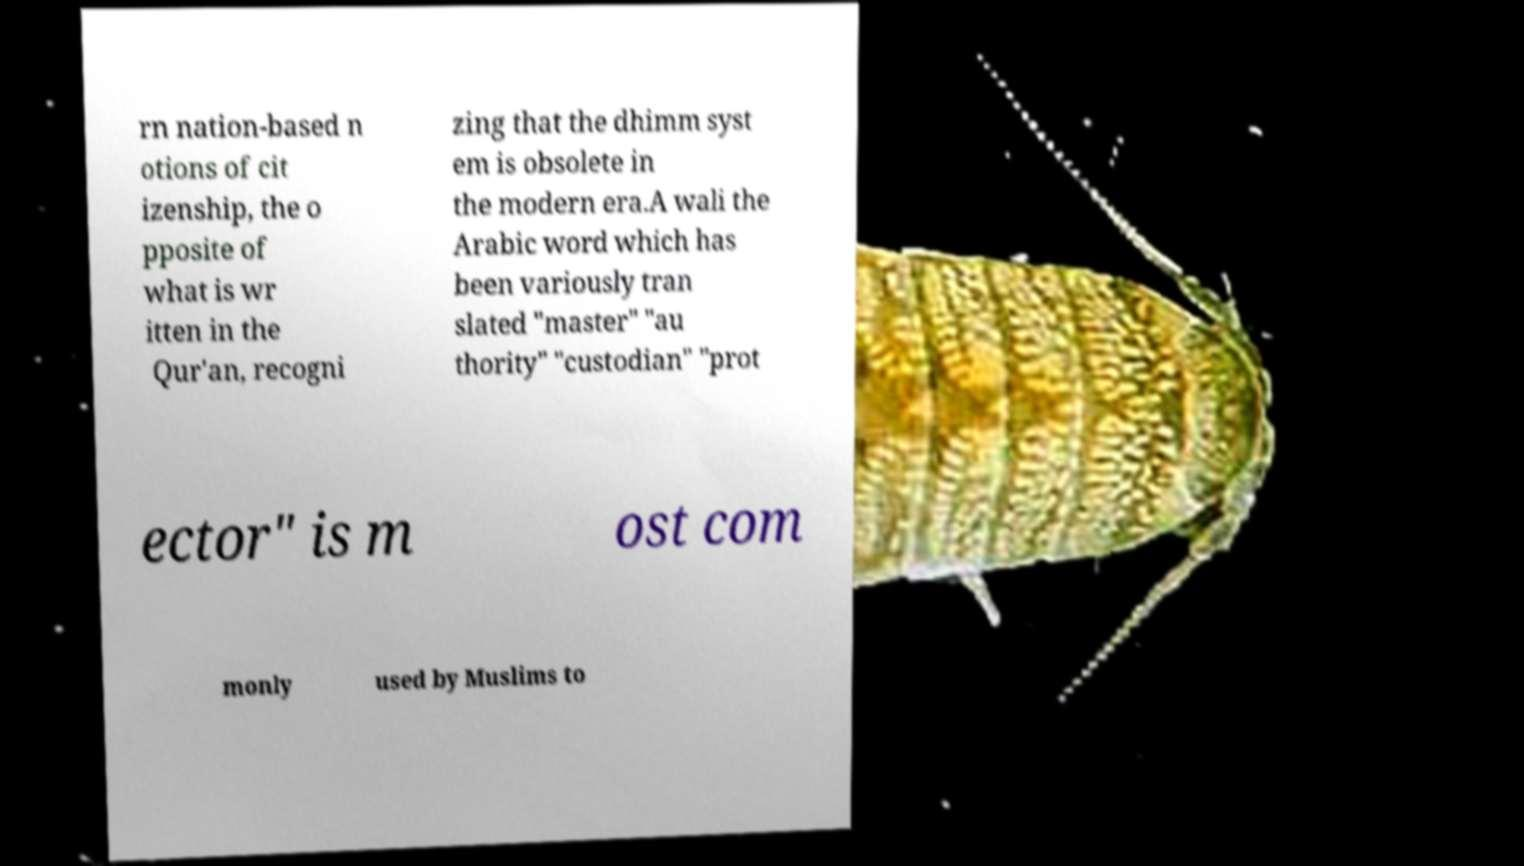What messages or text are displayed in this image? I need them in a readable, typed format. rn nation-based n otions of cit izenship, the o pposite of what is wr itten in the Qur'an, recogni zing that the dhimm syst em is obsolete in the modern era.A wali the Arabic word which has been variously tran slated "master" "au thority" "custodian" "prot ector" is m ost com monly used by Muslims to 